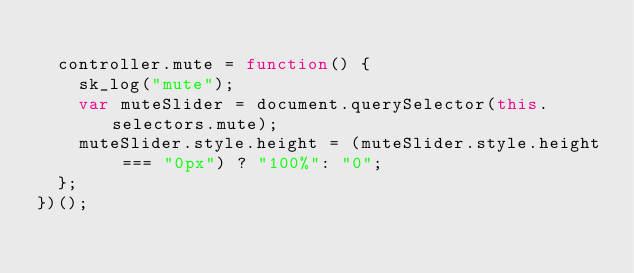Convert code to text. <code><loc_0><loc_0><loc_500><loc_500><_JavaScript_>
  controller.mute = function() {
    sk_log("mute");
    var muteSlider = document.querySelector(this.selectors.mute);
    muteSlider.style.height = (muteSlider.style.height === "0px") ? "100%": "0";
  };
})();
</code> 